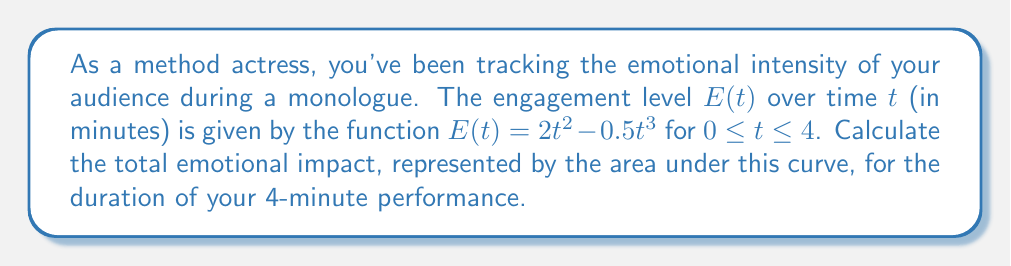Show me your answer to this math problem. To calculate the area under the curve, we need to integrate the function $E(t)$ from $t=0$ to $t=4$:

1) Set up the definite integral:
   $$\int_0^4 (2t^2 - 0.5t^3) dt$$

2) Integrate the function:
   $$\left[ \frac{2t^3}{3} - \frac{0.5t^4}{4} \right]_0^4$$

3) Evaluate the integral at the upper and lower bounds:
   $$\left( \frac{2(4^3)}{3} - \frac{0.5(4^4)}{4} \right) - \left( \frac{2(0^3)}{3} - \frac{0.5(0^4)}{4} \right)$$

4) Simplify:
   $$\left( \frac{128}{3} - 32 \right) - 0$$
   
   $$\frac{128}{3} - 32$$

5) Find a common denominator:
   $$\frac{128}{3} - \frac{96}{3} = \frac{32}{3}$$

Thus, the total emotional impact, represented by the area under the curve, is $\frac{32}{3}$ emotional intensity-minutes.
Answer: $\frac{32}{3}$ emotional intensity-minutes 